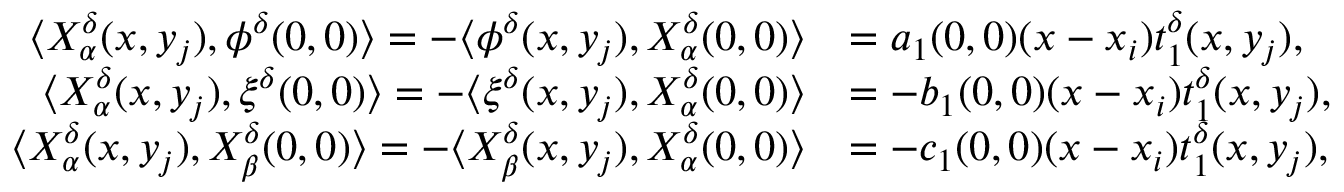<formula> <loc_0><loc_0><loc_500><loc_500>\begin{array} { r l } { \langle X _ { \alpha } ^ { \delta } ( x , y _ { j } ) , \phi ^ { \delta } ( 0 , 0 ) \rangle = - \langle \phi ^ { \delta } ( x , y _ { j } ) , X _ { \alpha } ^ { \delta } ( 0 , 0 ) \rangle } & { = a _ { 1 } ( 0 , 0 ) ( x - x _ { i } ) t _ { 1 } ^ { \delta } ( x , y _ { j } ) , } \\ { \langle X _ { \alpha } ^ { \delta } ( x , y _ { j } ) , \xi ^ { \delta } ( 0 , 0 ) \rangle = - \langle \xi ^ { \delta } ( x , y _ { j } ) , X _ { \alpha } ^ { \delta } ( 0 , 0 ) \rangle } & { = - b _ { 1 } ( 0 , 0 ) ( x - x _ { i } ) t _ { 1 } ^ { \delta } ( x , y _ { j } ) , } \\ { \langle X _ { \alpha } ^ { \delta } ( x , y _ { j } ) , X _ { \beta } ^ { \delta } ( 0 , 0 ) \rangle = - \langle X _ { \beta } ^ { \delta } ( x , y _ { j } ) , X _ { \alpha } ^ { \delta } ( 0 , 0 ) \rangle } & { = - c _ { 1 } ( 0 , 0 ) ( x - x _ { i } ) t _ { 1 } ^ { \delta } ( x , y _ { j } ) , } \end{array}</formula> 